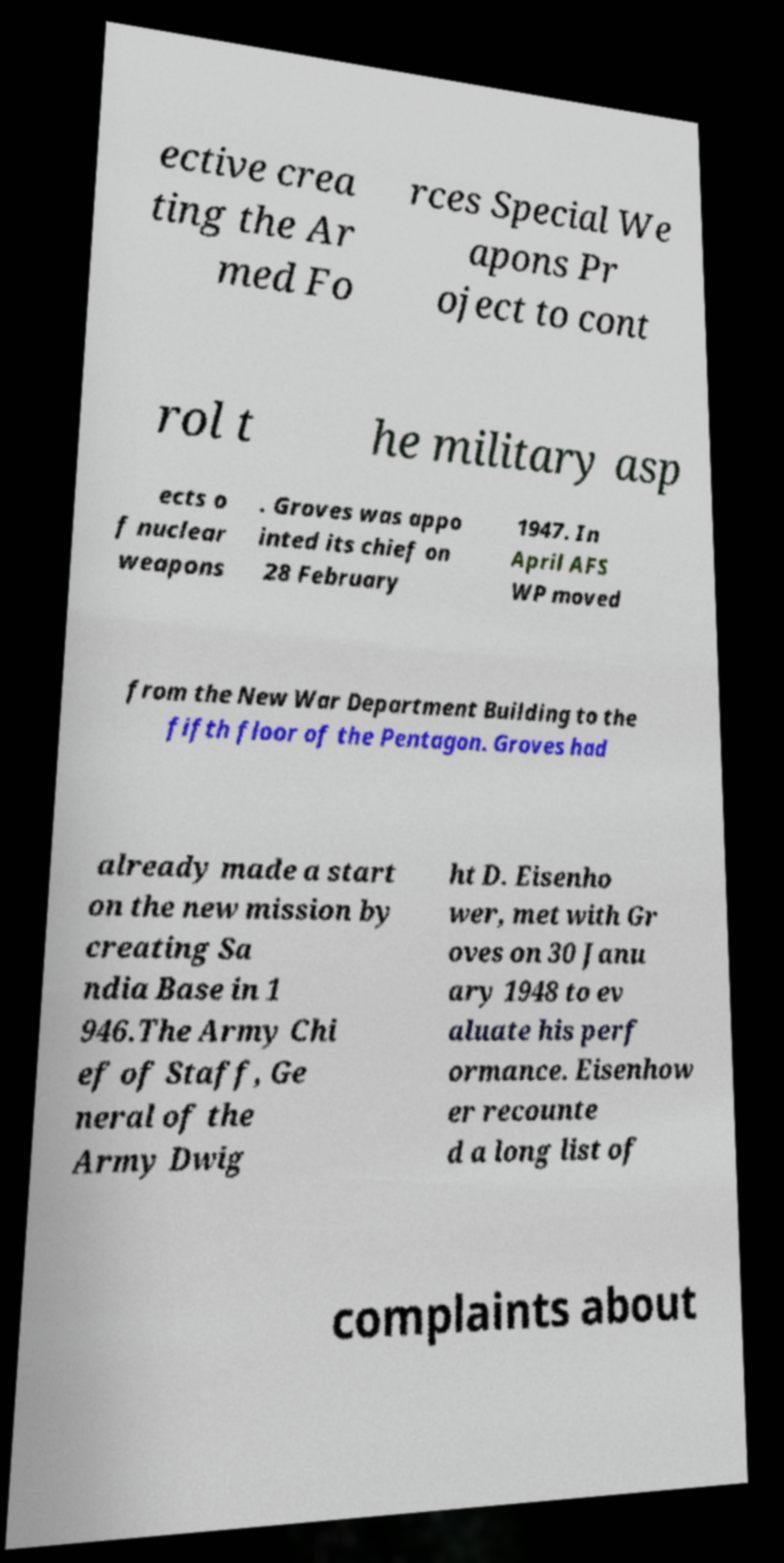Could you extract and type out the text from this image? ective crea ting the Ar med Fo rces Special We apons Pr oject to cont rol t he military asp ects o f nuclear weapons . Groves was appo inted its chief on 28 February 1947. In April AFS WP moved from the New War Department Building to the fifth floor of the Pentagon. Groves had already made a start on the new mission by creating Sa ndia Base in 1 946.The Army Chi ef of Staff, Ge neral of the Army Dwig ht D. Eisenho wer, met with Gr oves on 30 Janu ary 1948 to ev aluate his perf ormance. Eisenhow er recounte d a long list of complaints about 